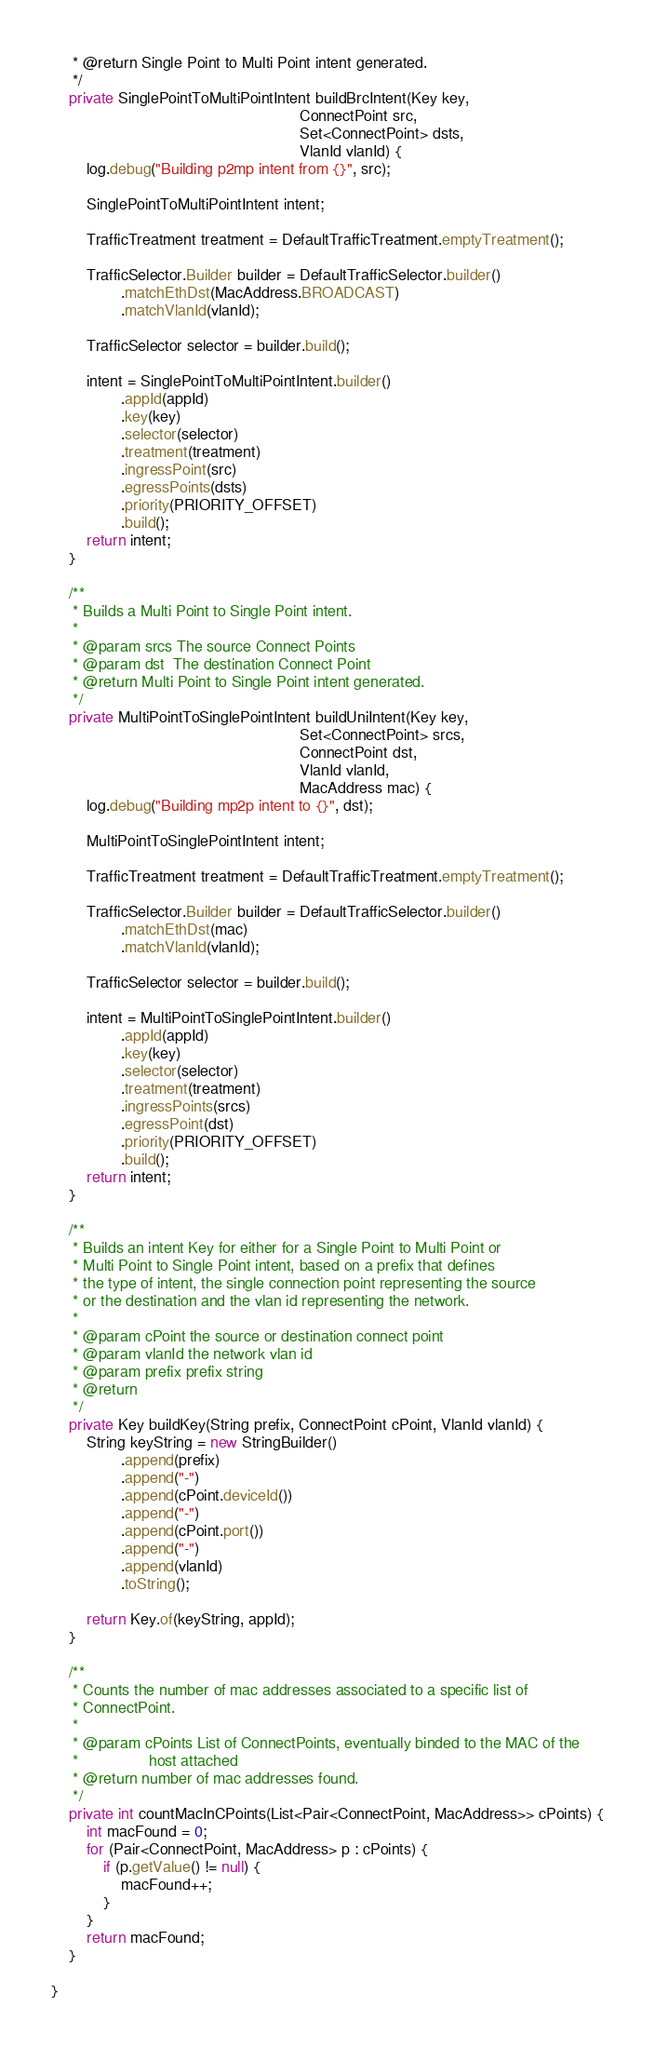<code> <loc_0><loc_0><loc_500><loc_500><_Java_>     * @return Single Point to Multi Point intent generated.
     */
    private SinglePointToMultiPointIntent buildBrcIntent(Key key,
                                                         ConnectPoint src,
                                                         Set<ConnectPoint> dsts,
                                                         VlanId vlanId) {
        log.debug("Building p2mp intent from {}", src);

        SinglePointToMultiPointIntent intent;

        TrafficTreatment treatment = DefaultTrafficTreatment.emptyTreatment();

        TrafficSelector.Builder builder = DefaultTrafficSelector.builder()
                .matchEthDst(MacAddress.BROADCAST)
                .matchVlanId(vlanId);

        TrafficSelector selector = builder.build();

        intent = SinglePointToMultiPointIntent.builder()
                .appId(appId)
                .key(key)
                .selector(selector)
                .treatment(treatment)
                .ingressPoint(src)
                .egressPoints(dsts)
                .priority(PRIORITY_OFFSET)
                .build();
        return intent;
    }

    /**
     * Builds a Multi Point to Single Point intent.
     *
     * @param srcs The source Connect Points
     * @param dst  The destination Connect Point
     * @return Multi Point to Single Point intent generated.
     */
    private MultiPointToSinglePointIntent buildUniIntent(Key key,
                                                         Set<ConnectPoint> srcs,
                                                         ConnectPoint dst,
                                                         VlanId vlanId,
                                                         MacAddress mac) {
        log.debug("Building mp2p intent to {}", dst);

        MultiPointToSinglePointIntent intent;

        TrafficTreatment treatment = DefaultTrafficTreatment.emptyTreatment();

        TrafficSelector.Builder builder = DefaultTrafficSelector.builder()
                .matchEthDst(mac)
                .matchVlanId(vlanId);

        TrafficSelector selector = builder.build();

        intent = MultiPointToSinglePointIntent.builder()
                .appId(appId)
                .key(key)
                .selector(selector)
                .treatment(treatment)
                .ingressPoints(srcs)
                .egressPoint(dst)
                .priority(PRIORITY_OFFSET)
                .build();
        return intent;
    }

    /**
     * Builds an intent Key for either for a Single Point to Multi Point or
     * Multi Point to Single Point intent, based on a prefix that defines
     * the type of intent, the single connection point representing the source
     * or the destination and the vlan id representing the network.
     *
     * @param cPoint the source or destination connect point
     * @param vlanId the network vlan id
     * @param prefix prefix string
     * @return
     */
    private Key buildKey(String prefix, ConnectPoint cPoint, VlanId vlanId) {
        String keyString = new StringBuilder()
                .append(prefix)
                .append("-")
                .append(cPoint.deviceId())
                .append("-")
                .append(cPoint.port())
                .append("-")
                .append(vlanId)
                .toString();

        return Key.of(keyString, appId);
    }

    /**
     * Counts the number of mac addresses associated to a specific list of
     * ConnectPoint.
     *
     * @param cPoints List of ConnectPoints, eventually binded to the MAC of the
     *                host attached
     * @return number of mac addresses found.
     */
    private int countMacInCPoints(List<Pair<ConnectPoint, MacAddress>> cPoints) {
        int macFound = 0;
        for (Pair<ConnectPoint, MacAddress> p : cPoints) {
            if (p.getValue() != null) {
                macFound++;
            }
        }
        return macFound;
    }

}
</code> 